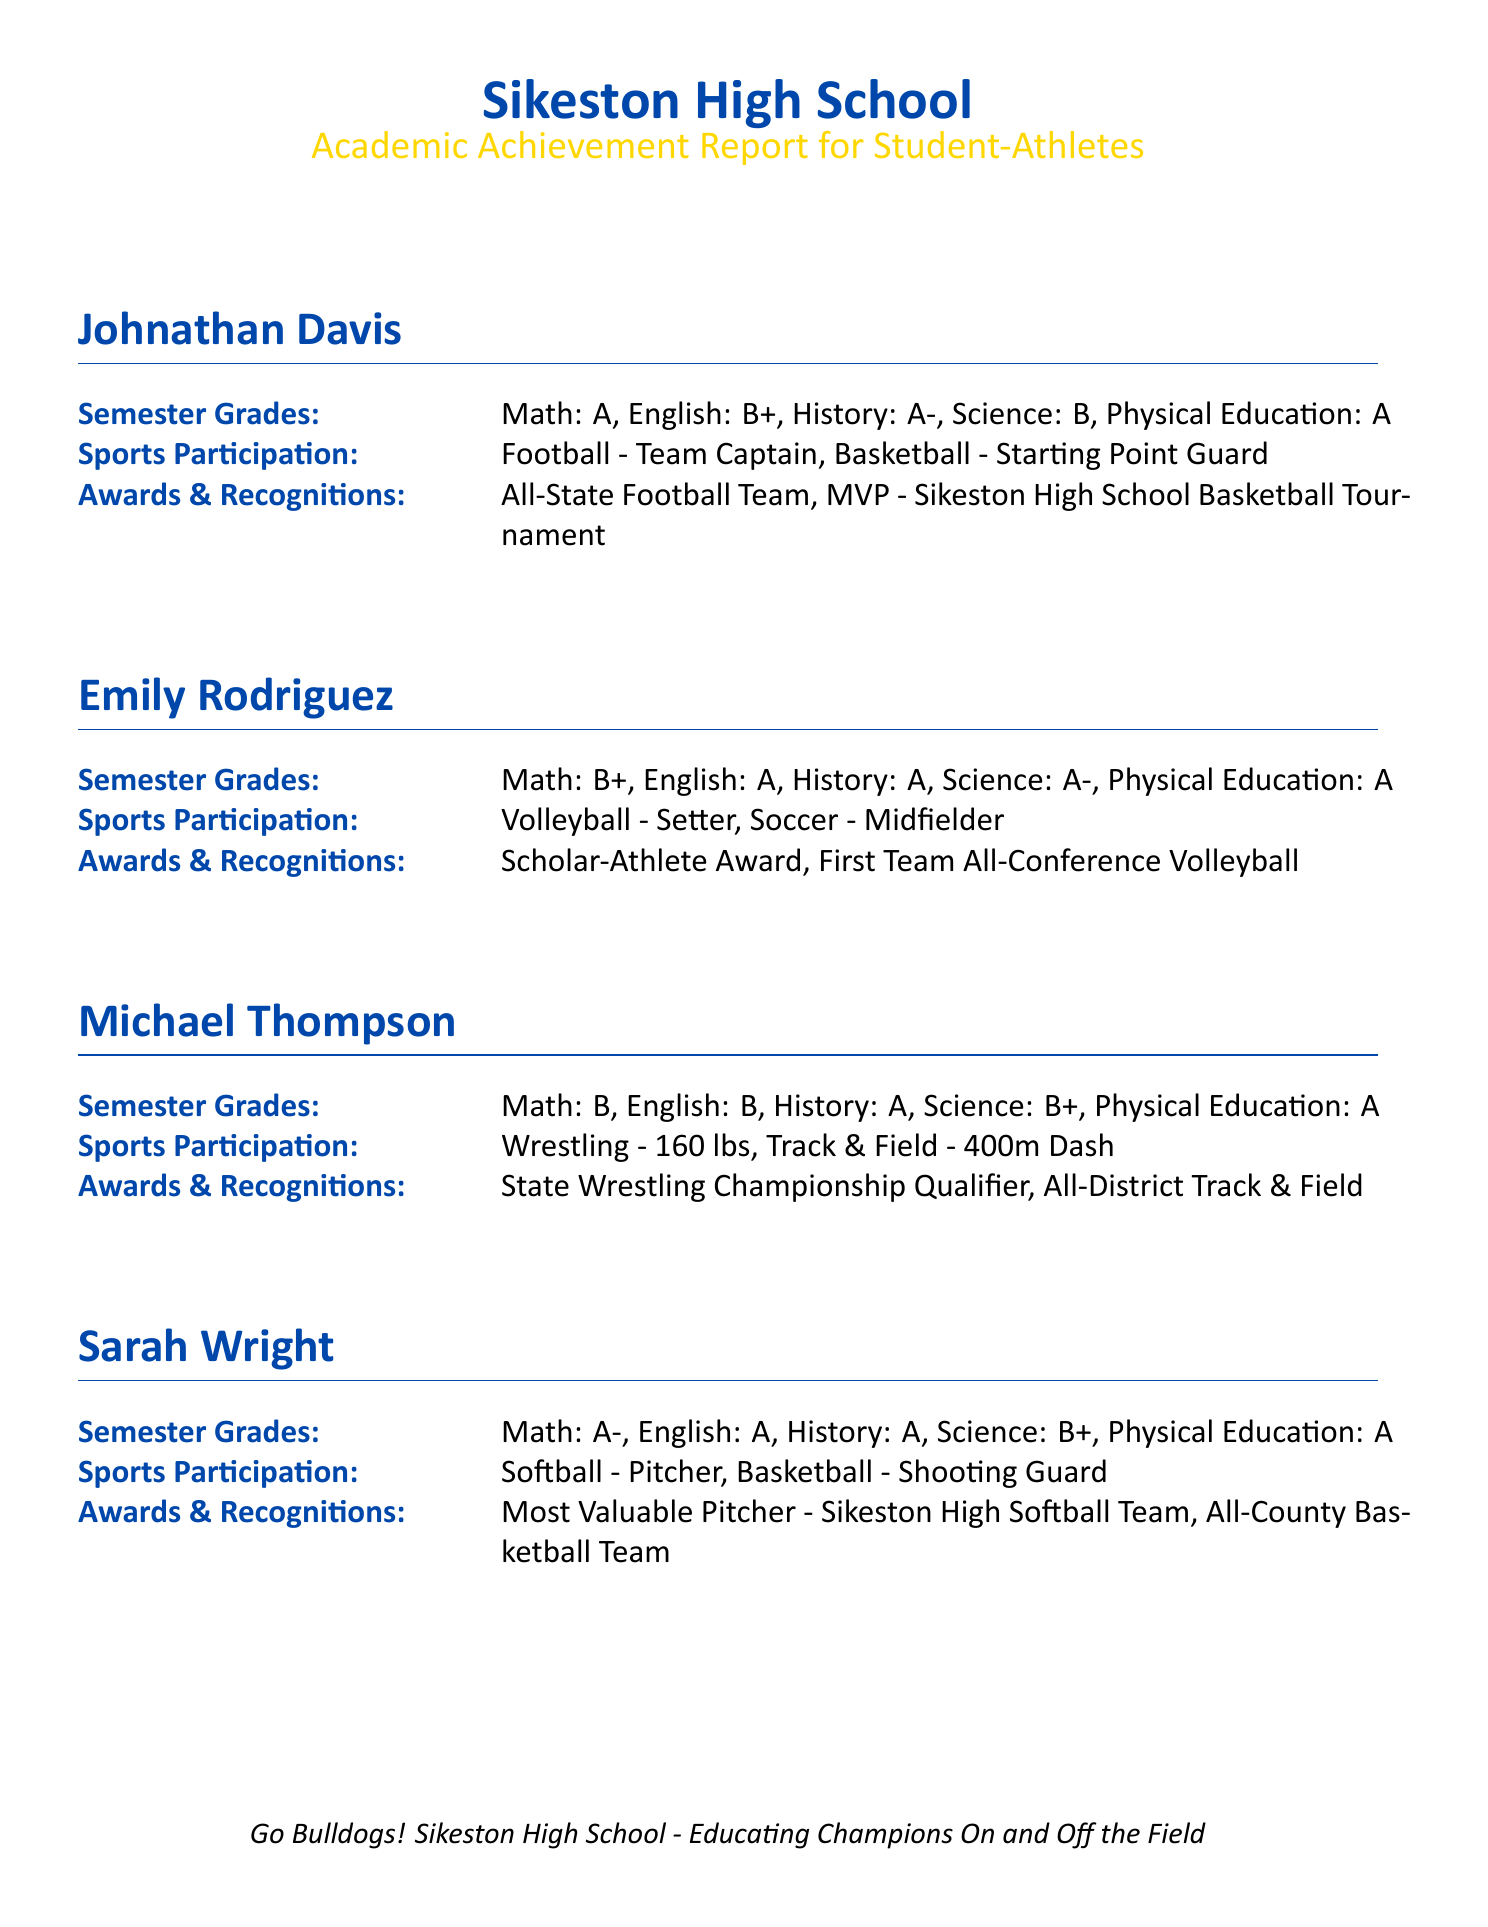What is Johnathan Davis's grade in English? The document lists his semester grades, including a B+ in English.
Answer: B+ Which sport is Emily Rodriguez the Setter in? The document states her participation in volleyball, where she plays as a Setter.
Answer: Volleyball How many awards did Sarah Wright receive? The document mentions two specific awards she received for her participation in sports.
Answer: Two What position does Michael Thompson compete in for wrestling? The document indicates that he competes in the 160 lbs category in wrestling.
Answer: 160 lbs What is the overall theme of the academic achievement report? The document concludes with a statement emphasizing educational achievements both on and off the field.
Answer: Educating Champions On and Off the Field Which award did Emily Rodriguez receive for her academic success? The document specifies that she received the Scholar-Athlete Award.
Answer: Scholar-Athlete Award How many sports does Johnathan Davis participate in? The document indicates that he is involved in two sports, football and basketball.
Answer: Two What was Sarah Wright's semester grade in Science? The document specifies her grade as B+ in Science.
Answer: B+ Which team did Michael Thompson qualify for in wrestling? The document notes that he qualified for the State Wrestling Championship.
Answer: State Wrestling Championship 